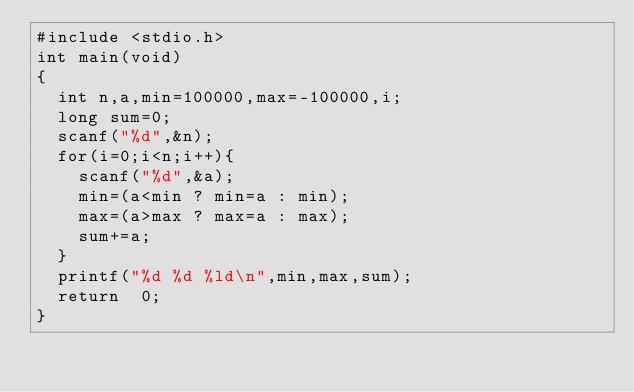Convert code to text. <code><loc_0><loc_0><loc_500><loc_500><_C_>#include <stdio.h>
int	main(void)
{
	int n,a,min=100000,max=-100000,i;
	long sum=0;
	scanf("%d",&n);
	for(i=0;i<n;i++){
		scanf("%d",&a);
		min=(a<min ? min=a : min);
		max=(a>max ? max=a : max);
		sum+=a;
	}
	printf("%d %d %ld\n",min,max,sum);
	return	0;
}</code> 